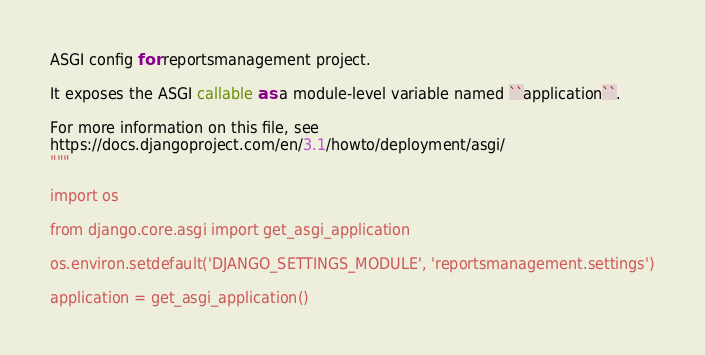<code> <loc_0><loc_0><loc_500><loc_500><_Python_>ASGI config for reportsmanagement project.

It exposes the ASGI callable as a module-level variable named ``application``.

For more information on this file, see
https://docs.djangoproject.com/en/3.1/howto/deployment/asgi/
"""

import os

from django.core.asgi import get_asgi_application

os.environ.setdefault('DJANGO_SETTINGS_MODULE', 'reportsmanagement.settings')

application = get_asgi_application()
</code> 